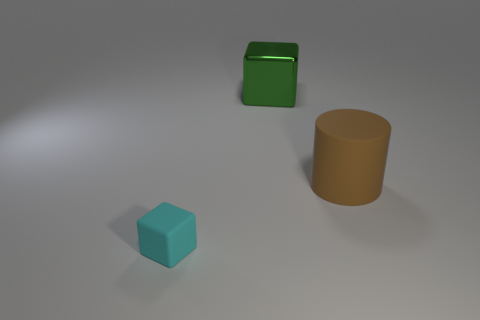Add 1 big gray objects. How many objects exist? 4 Add 3 large cubes. How many large cubes exist? 4 Subtract 0 purple spheres. How many objects are left? 3 Subtract all cylinders. How many objects are left? 2 Subtract all metallic things. Subtract all green blocks. How many objects are left? 1 Add 3 cyan objects. How many cyan objects are left? 4 